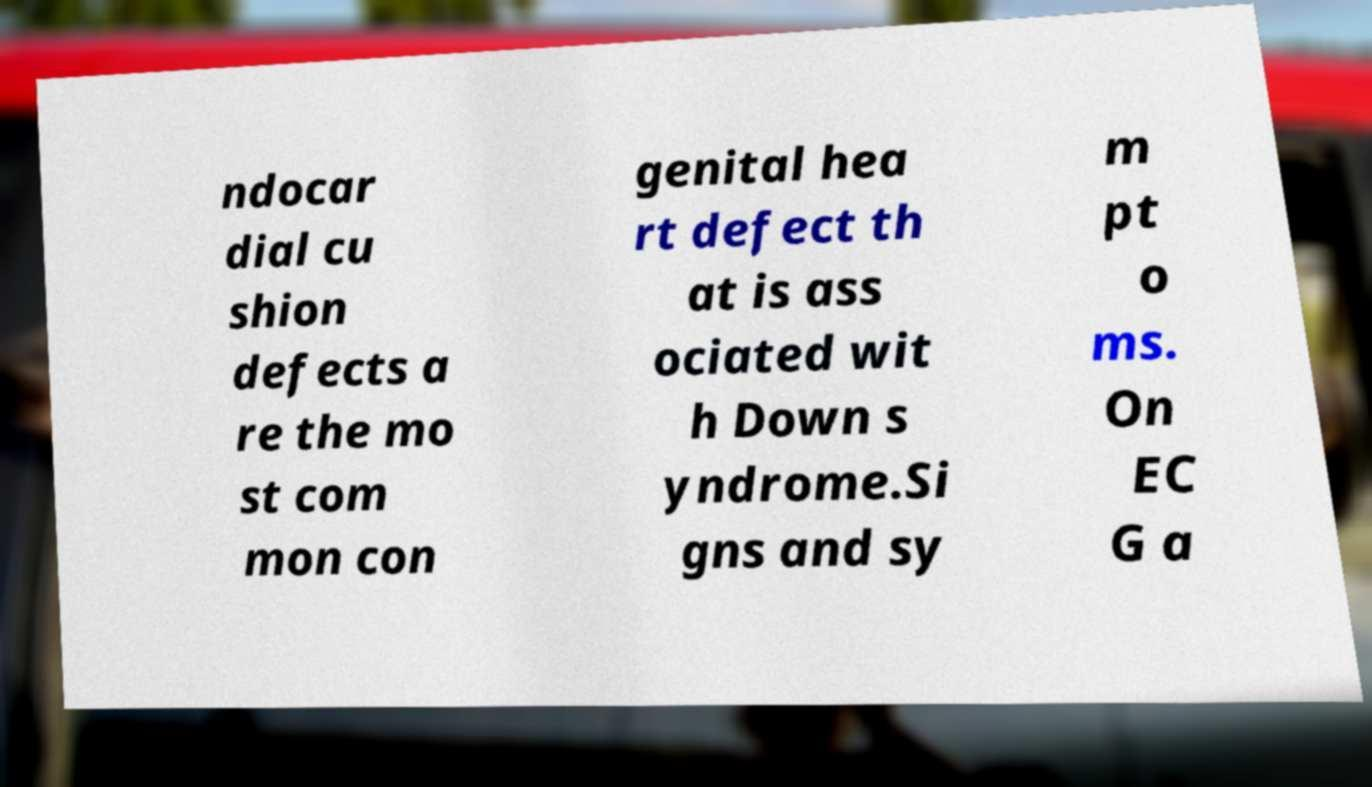For documentation purposes, I need the text within this image transcribed. Could you provide that? ndocar dial cu shion defects a re the mo st com mon con genital hea rt defect th at is ass ociated wit h Down s yndrome.Si gns and sy m pt o ms. On EC G a 